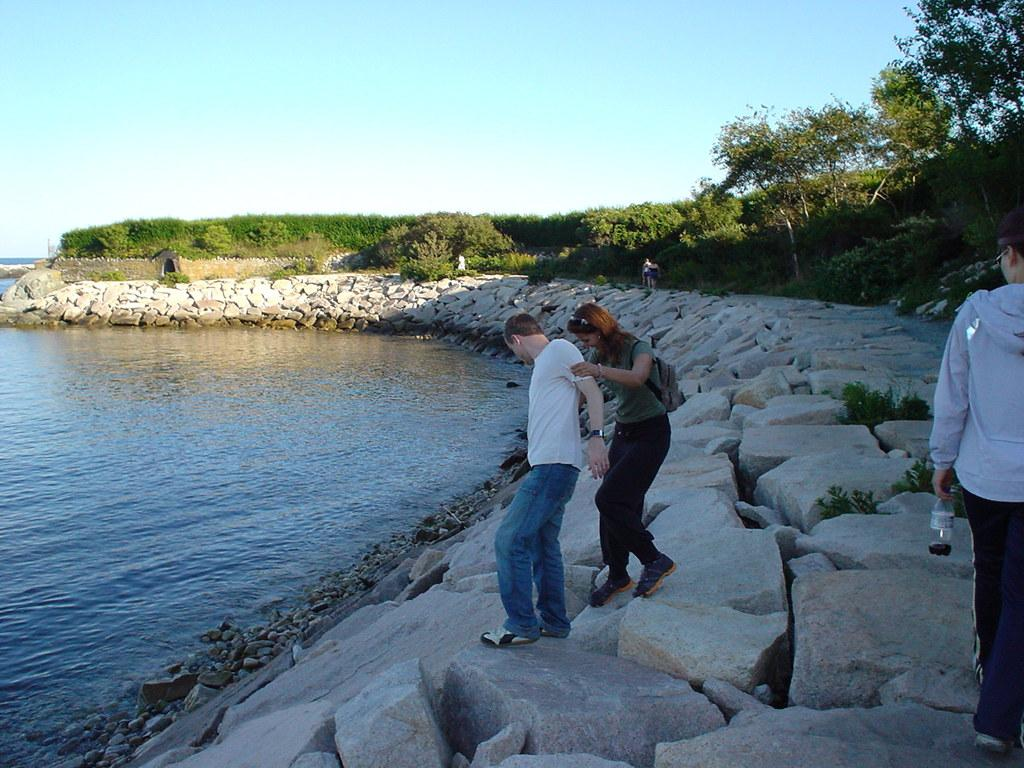What are the people in the image standing on? The people in the image are standing on rocks. What can be seen on the left side of the image? There is water on the left side of the image. What type of vegetation is visible in the image? There are plants and trees visible in the image. What is visible in the background of the image? The sky is visible in the background of the image. Can you see any quartz in the image? There is no quartz visible in the image. How many cattle are present in the image? There are no cattle present in the image. 